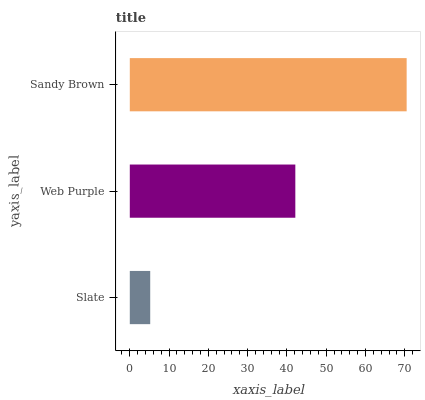Is Slate the minimum?
Answer yes or no. Yes. Is Sandy Brown the maximum?
Answer yes or no. Yes. Is Web Purple the minimum?
Answer yes or no. No. Is Web Purple the maximum?
Answer yes or no. No. Is Web Purple greater than Slate?
Answer yes or no. Yes. Is Slate less than Web Purple?
Answer yes or no. Yes. Is Slate greater than Web Purple?
Answer yes or no. No. Is Web Purple less than Slate?
Answer yes or no. No. Is Web Purple the high median?
Answer yes or no. Yes. Is Web Purple the low median?
Answer yes or no. Yes. Is Sandy Brown the high median?
Answer yes or no. No. Is Slate the low median?
Answer yes or no. No. 